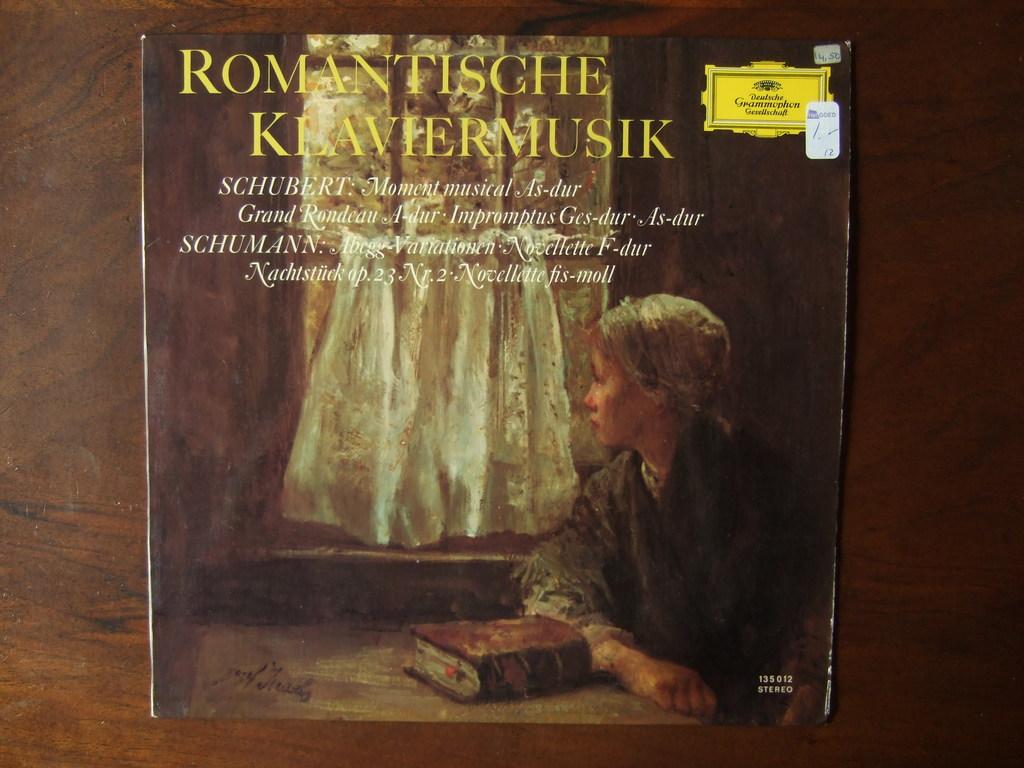What record is this?
Keep it short and to the point. Romantische klaviermusik. 